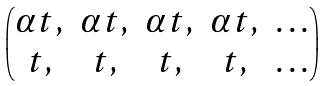Convert formula to latex. <formula><loc_0><loc_0><loc_500><loc_500>\begin{pmatrix} \alpha t , & \alpha t , & \alpha t , & \alpha t , & \dots \\ t , & t , & t , & t , & \dots \end{pmatrix}</formula> 